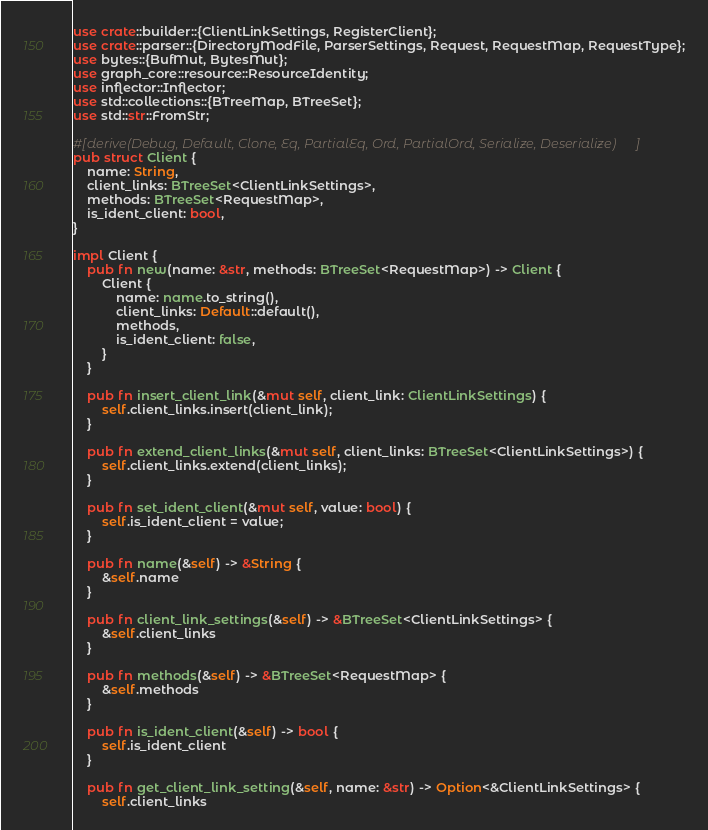Convert code to text. <code><loc_0><loc_0><loc_500><loc_500><_Rust_>use crate::builder::{ClientLinkSettings, RegisterClient};
use crate::parser::{DirectoryModFile, ParserSettings, Request, RequestMap, RequestType};
use bytes::{BufMut, BytesMut};
use graph_core::resource::ResourceIdentity;
use inflector::Inflector;
use std::collections::{BTreeMap, BTreeSet};
use std::str::FromStr;

#[derive(Debug, Default, Clone, Eq, PartialEq, Ord, PartialOrd, Serialize, Deserialize)]
pub struct Client {
    name: String,
    client_links: BTreeSet<ClientLinkSettings>,
    methods: BTreeSet<RequestMap>,
    is_ident_client: bool,
}

impl Client {
    pub fn new(name: &str, methods: BTreeSet<RequestMap>) -> Client {
        Client {
            name: name.to_string(),
            client_links: Default::default(),
            methods,
            is_ident_client: false,
        }
    }

    pub fn insert_client_link(&mut self, client_link: ClientLinkSettings) {
        self.client_links.insert(client_link);
    }

    pub fn extend_client_links(&mut self, client_links: BTreeSet<ClientLinkSettings>) {
        self.client_links.extend(client_links);
    }

    pub fn set_ident_client(&mut self, value: bool) {
        self.is_ident_client = value;
    }

    pub fn name(&self) -> &String {
        &self.name
    }

    pub fn client_link_settings(&self) -> &BTreeSet<ClientLinkSettings> {
        &self.client_links
    }

    pub fn methods(&self) -> &BTreeSet<RequestMap> {
        &self.methods
    }

    pub fn is_ident_client(&self) -> bool {
        self.is_ident_client
    }

    pub fn get_client_link_setting(&self, name: &str) -> Option<&ClientLinkSettings> {
        self.client_links</code> 